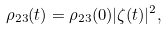Convert formula to latex. <formula><loc_0><loc_0><loc_500><loc_500>\rho _ { 2 3 } ( t ) = \rho _ { 2 3 } ( 0 ) | \zeta ( t ) | ^ { 2 } ,</formula> 